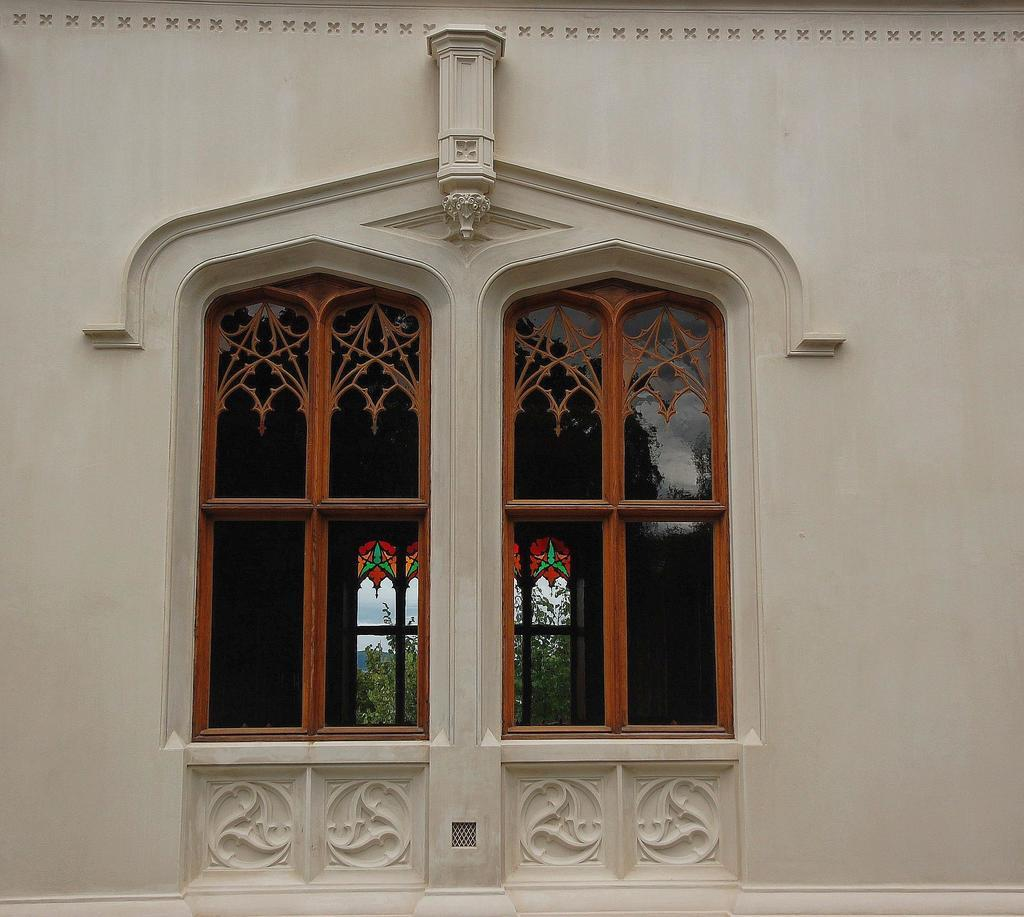What type of structure can be seen in the image? There is a wall in the image. What material is used for the windows in the image? The windows in the image are made of glass. What can be seen through the windows in the background? Trees and the sky are visible through the windows in the background. What type of scent can be smelled coming from the cellar in the image? There is no cellar present in the image, so it is not possible to determine what scent might be coming from it. 